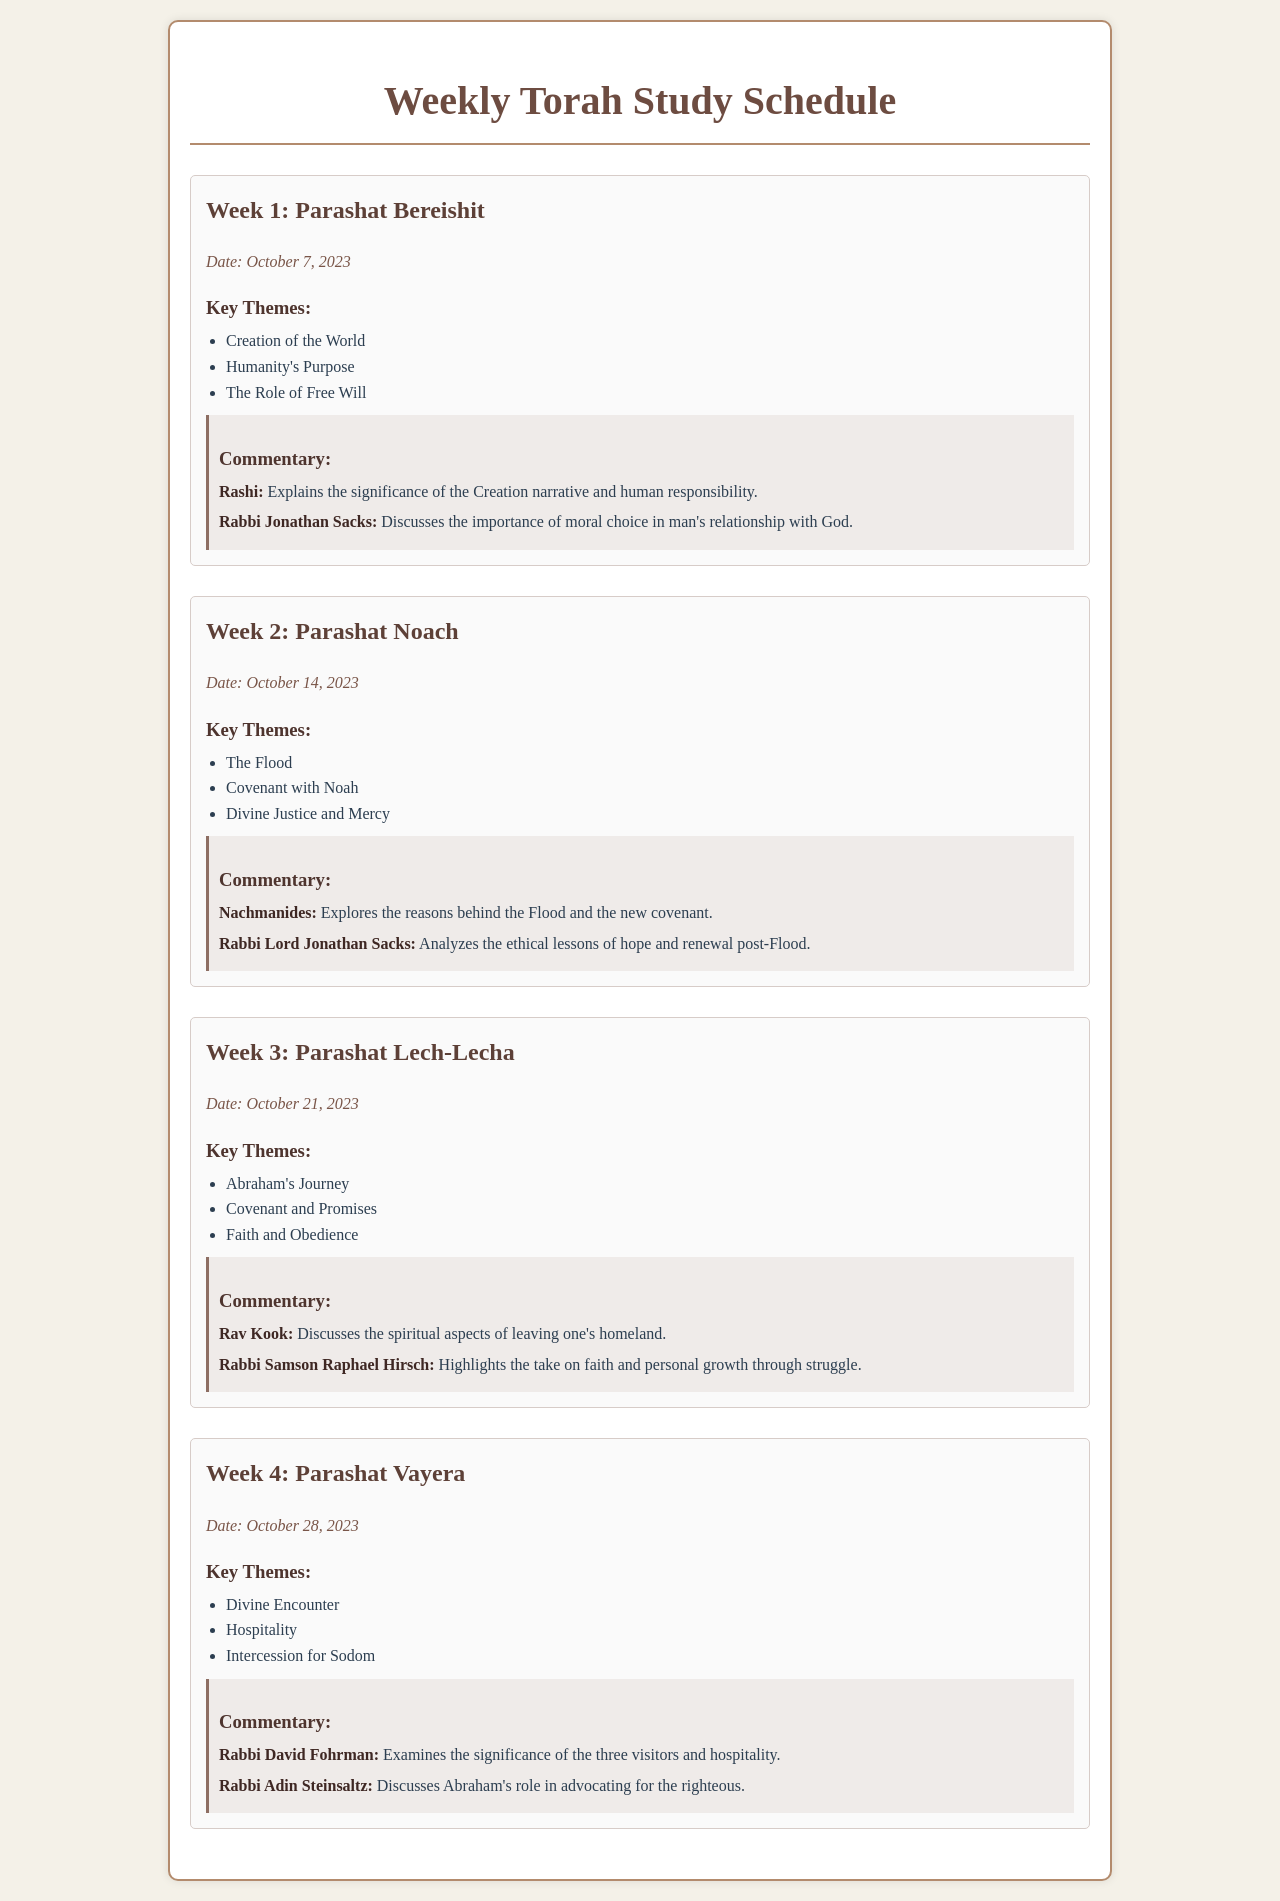What is the date for Parashat Bereishit? The date given in the document for Parashat Bereishit is specifically stated under the section for Week 1.
Answer: October 7, 2023 Who authored the commentary on Parashat Lech-Lecha? The document lists authors for the commentary on each Parashat, including for Lech-Lecha.
Answer: Rav Kook What is one of the key themes of Parashat Vayera? The key themes are summarized in a list format under each week's section, including Vayera.
Answer: Divine Encounter How many weeks are outlined in the schedule? The document contains information for four weeks, each detailing a different Parashat.
Answer: 4 What is a key theme discussed in Parashat Noach? The themes are listed, and this question refers specifically to one of them presented in Week 2.
Answer: Divine Justice and Mercy Who discusses the significance of the three visitors in Parashat Vayera? The document specifies the authors who contribute commentary on each Parashat, including Vayera.
Answer: Rabbi David Fohrman What is the main focus of the commentary for Parashat Noach? The document specifies the content of the commentary for each Parashat, indicating focal points of discussion.
Answer: The reasons behind the Flood and the new covenant What is the title of the document? The title is stated at the top of the rendered document and gives a clear indication of its content.
Answer: Weekly Torah Study Schedule 